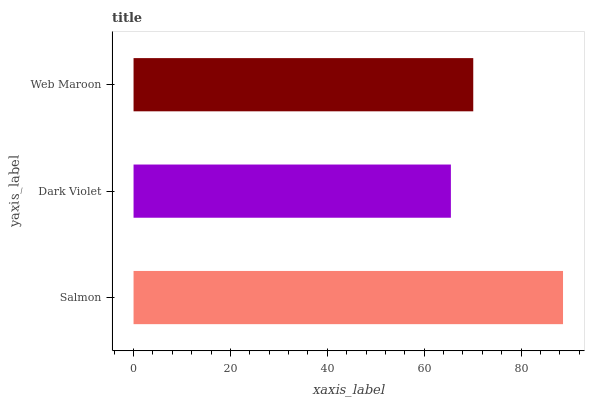Is Dark Violet the minimum?
Answer yes or no. Yes. Is Salmon the maximum?
Answer yes or no. Yes. Is Web Maroon the minimum?
Answer yes or no. No. Is Web Maroon the maximum?
Answer yes or no. No. Is Web Maroon greater than Dark Violet?
Answer yes or no. Yes. Is Dark Violet less than Web Maroon?
Answer yes or no. Yes. Is Dark Violet greater than Web Maroon?
Answer yes or no. No. Is Web Maroon less than Dark Violet?
Answer yes or no. No. Is Web Maroon the high median?
Answer yes or no. Yes. Is Web Maroon the low median?
Answer yes or no. Yes. Is Salmon the high median?
Answer yes or no. No. Is Dark Violet the low median?
Answer yes or no. No. 